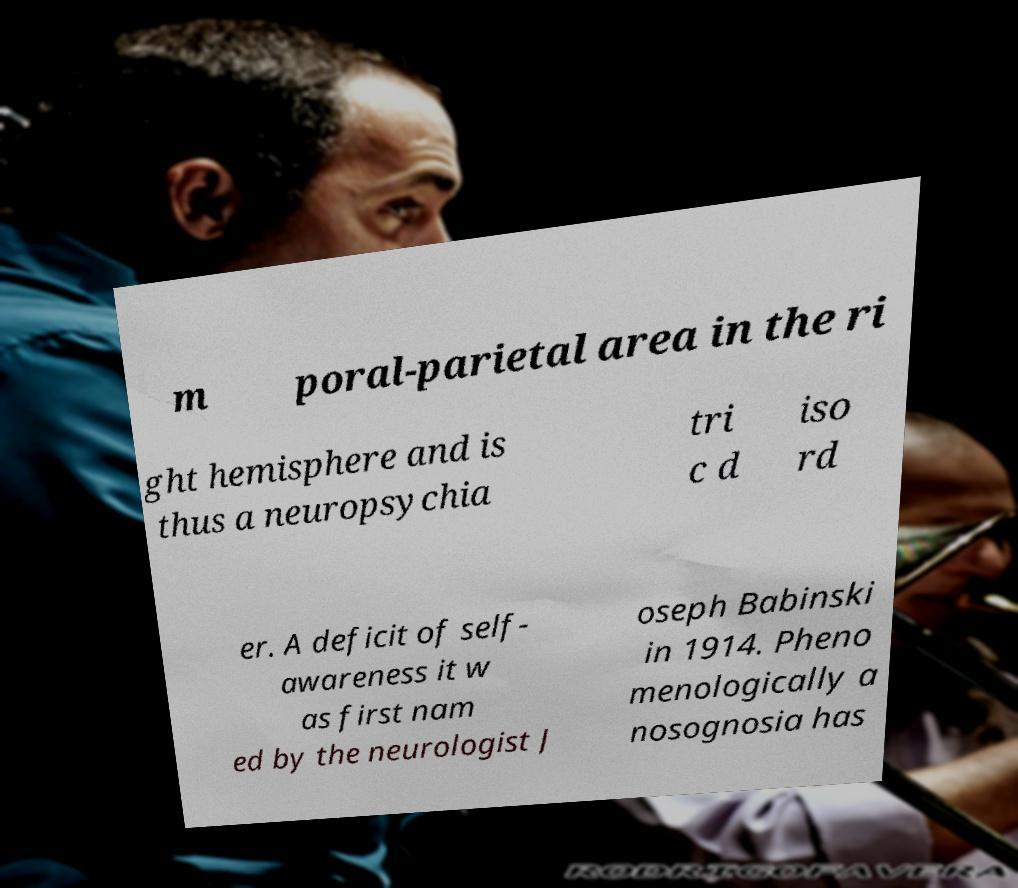There's text embedded in this image that I need extracted. Can you transcribe it verbatim? m poral-parietal area in the ri ght hemisphere and is thus a neuropsychia tri c d iso rd er. A deficit of self- awareness it w as first nam ed by the neurologist J oseph Babinski in 1914. Pheno menologically a nosognosia has 